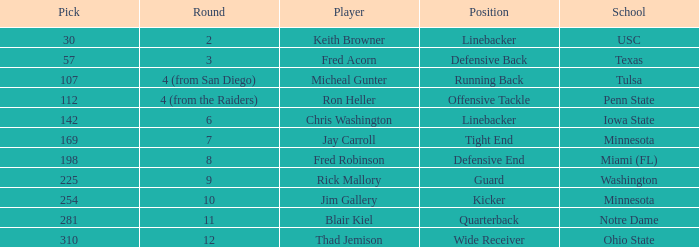What is the highest pick from Washington? 225.0. 